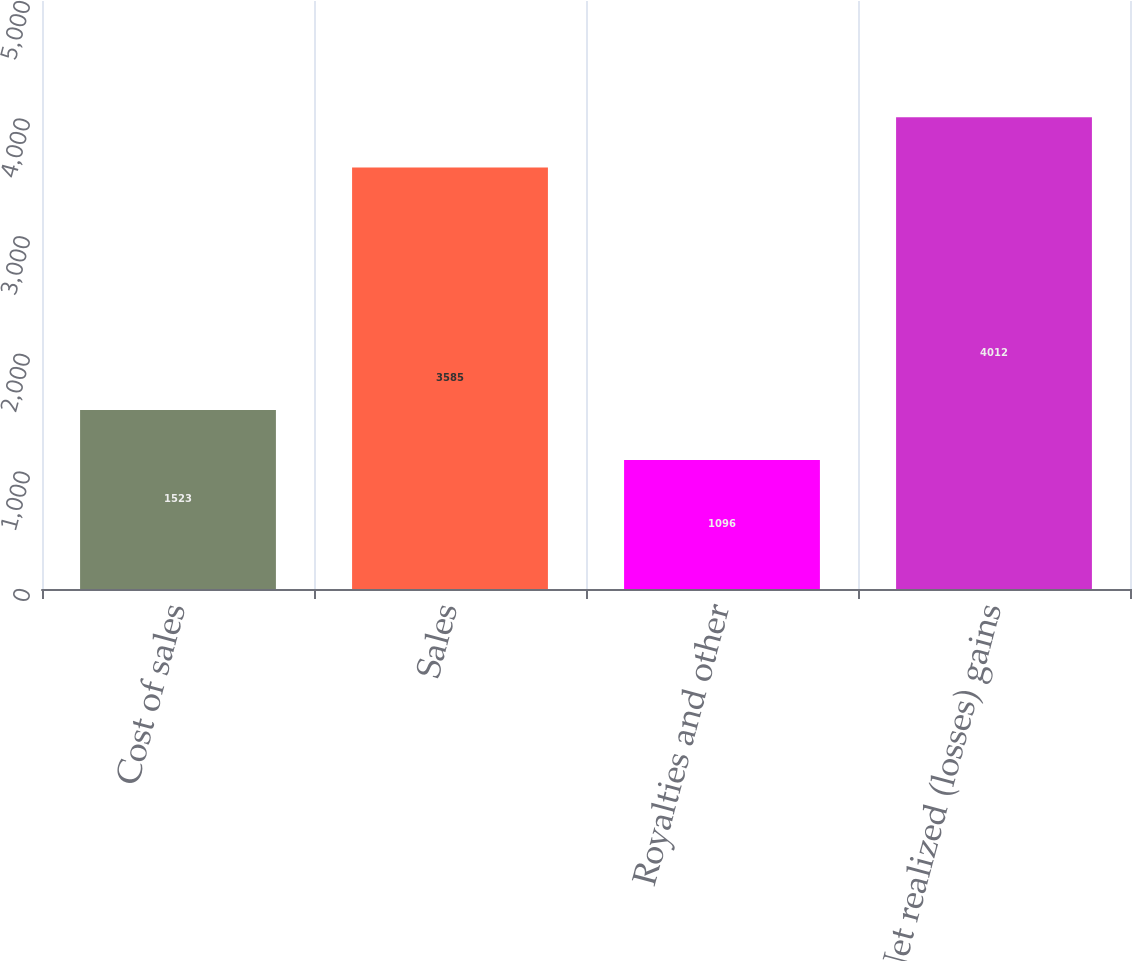Convert chart to OTSL. <chart><loc_0><loc_0><loc_500><loc_500><bar_chart><fcel>Cost of sales<fcel>Sales<fcel>Royalties and other<fcel>Net realized (losses) gains<nl><fcel>1523<fcel>3585<fcel>1096<fcel>4012<nl></chart> 